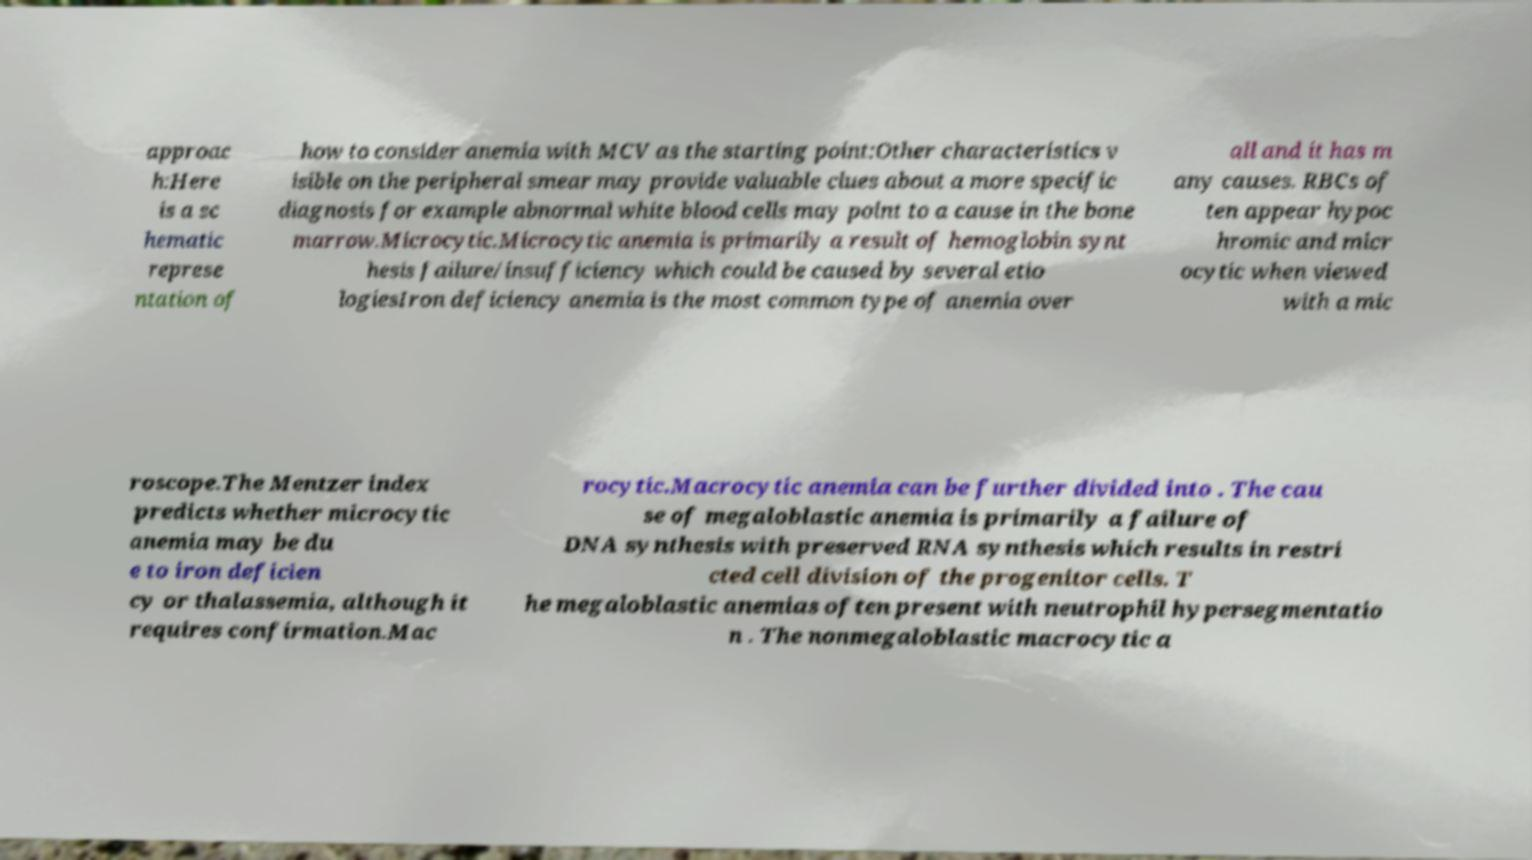Can you accurately transcribe the text from the provided image for me? approac h:Here is a sc hematic represe ntation of how to consider anemia with MCV as the starting point:Other characteristics v isible on the peripheral smear may provide valuable clues about a more specific diagnosis for example abnormal white blood cells may point to a cause in the bone marrow.Microcytic.Microcytic anemia is primarily a result of hemoglobin synt hesis failure/insufficiency which could be caused by several etio logiesIron deficiency anemia is the most common type of anemia over all and it has m any causes. RBCs of ten appear hypoc hromic and micr ocytic when viewed with a mic roscope.The Mentzer index predicts whether microcytic anemia may be du e to iron deficien cy or thalassemia, although it requires confirmation.Mac rocytic.Macrocytic anemia can be further divided into . The cau se of megaloblastic anemia is primarily a failure of DNA synthesis with preserved RNA synthesis which results in restri cted cell division of the progenitor cells. T he megaloblastic anemias often present with neutrophil hypersegmentatio n . The nonmegaloblastic macrocytic a 